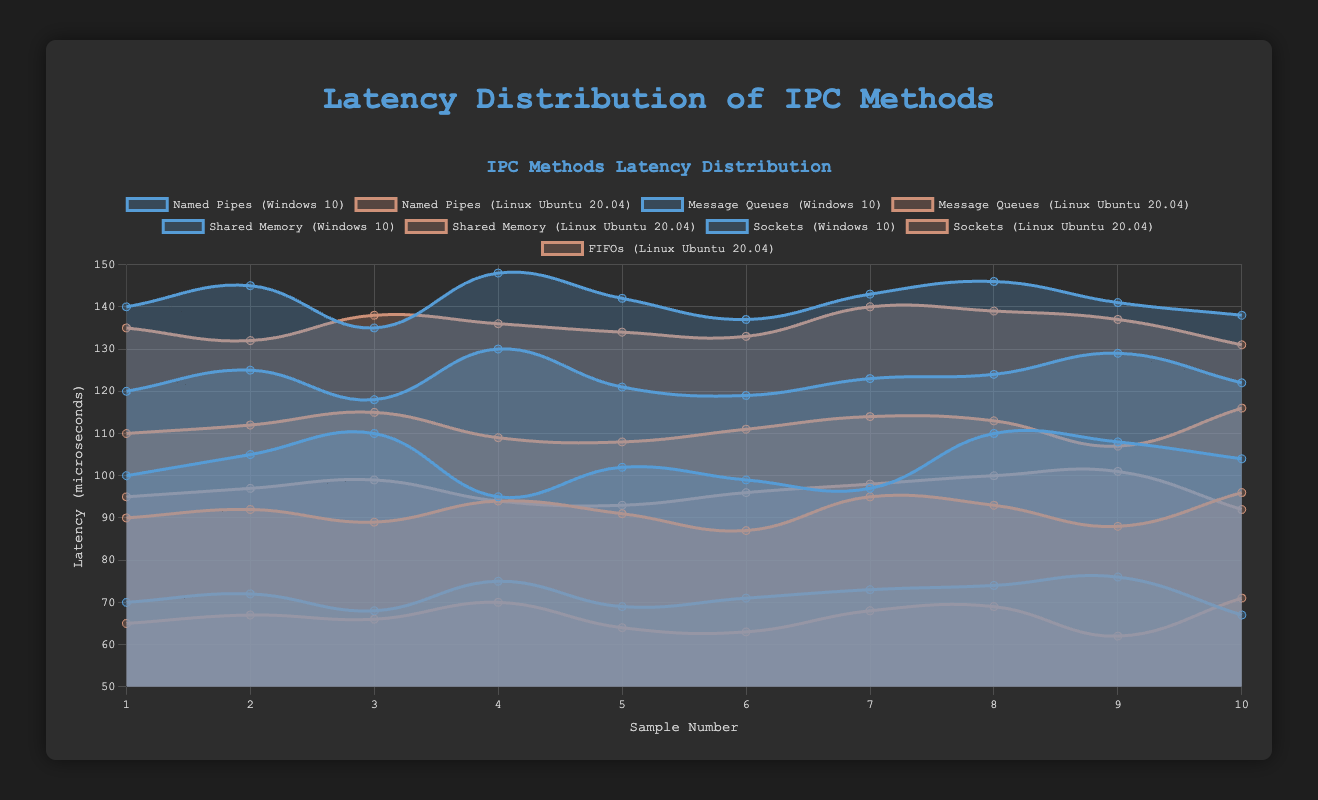Which IPC method has the lowest average latency on Linux Ubuntu 20.04? By observing the data and finding the average latency for each IPC method, Shared Memory has the lowest average at 64.5 microseconds while Named Pipes, Message Queues, FIFOs, and Sockets have higher averages. Therefore, Shared Memory on Linux has the lowest average latency.
Answer: Shared Memory Comparing the average latencies, which operating system performs better for Named Pipes? Calculate the average latency for Named Pipes on both Windows 10 and Linux Ubuntu 20.04. The averages are 103 and 91.5 microseconds respectively, making Linux Ubuntu 20.04 the better performer for Named Pipes.
Answer: Linux Ubuntu 20.04 Which IPC method exhibits the highest latency on Windows 10? By comparing the latency values for IPC methods on Windows 10, Sockets have the highest latencies across the samples with values up to 148 microseconds.
Answer: Sockets How does the average latency of Sockets on Windows 10 compare to Linux Ubuntu 20.04? Calculate the average latency for Sockets on both Windows 10 (141.3) and Linux Ubuntu 20.04 (135.5). Sockets on Windows 10 have a higher average latency.
Answer: Windows 10 What is the difference between the highest and lowest latencies for Message Queues on Linux Ubuntu 20.04? The highest latency for Message Queues on Linux Ubuntu 20.04 is 116 microseconds and the lowest is 107 microseconds. The difference is 116 - 107 = 9 microseconds.
Answer: 9 Which dataset is depicted using a red color in the plot? The latency values for Linux Ubuntu 20.04 are depicted using a red color, specifically in the context of all IPC methods that are represented in the dataset.
Answer: Linux Ubuntu 20.04 What visual attribute indicates the different operating systems? Different operating systems are indicated by different colors: blue for Windows 10 and red for Linux Ubuntu 20.04.
Answer: Colors For which IPC method and operating system combination is the latency variance the highest? By examining the spread of data points, Message Queues on Windows 10 have the highest variance with latencies ranging from 118 to 130 microseconds.
Answer: Message Queues on Windows 10 If you consider only Sockets, which data points have the highest latency, and on which operating system? The highest latency data points for Sockets are 148 microseconds, and these belong to the Windows 10 operating system.
Answer: Windows 10 Overall, which IPC method tends to have the lowest latency values irrespective of the operating system? By evaluating all IPC methods, Shared Memory tends to have the lowest latency values compared to other methods, regardless of the operating system.
Answer: Shared Memory 